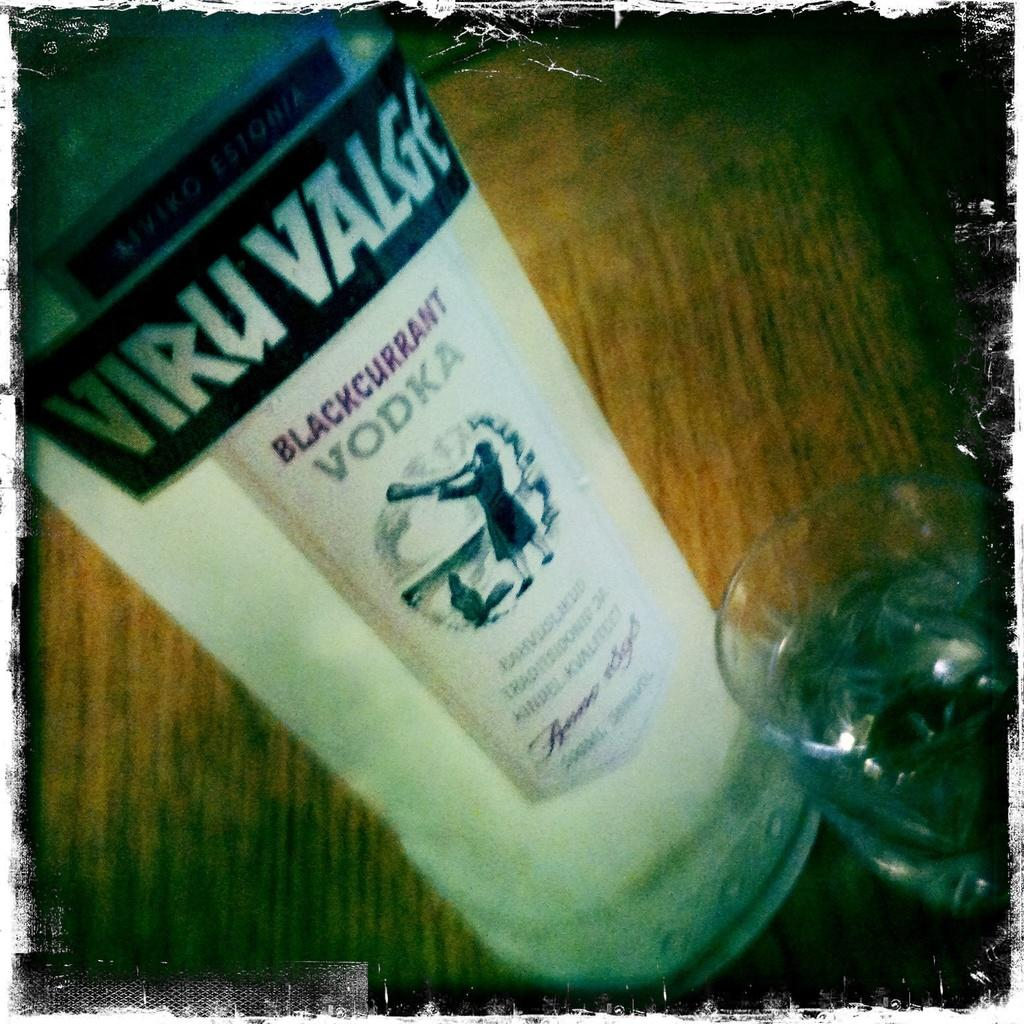<image>
Share a concise interpretation of the image provided. a bottle of blackcurrant vodka that says 'viru valge' at the top 